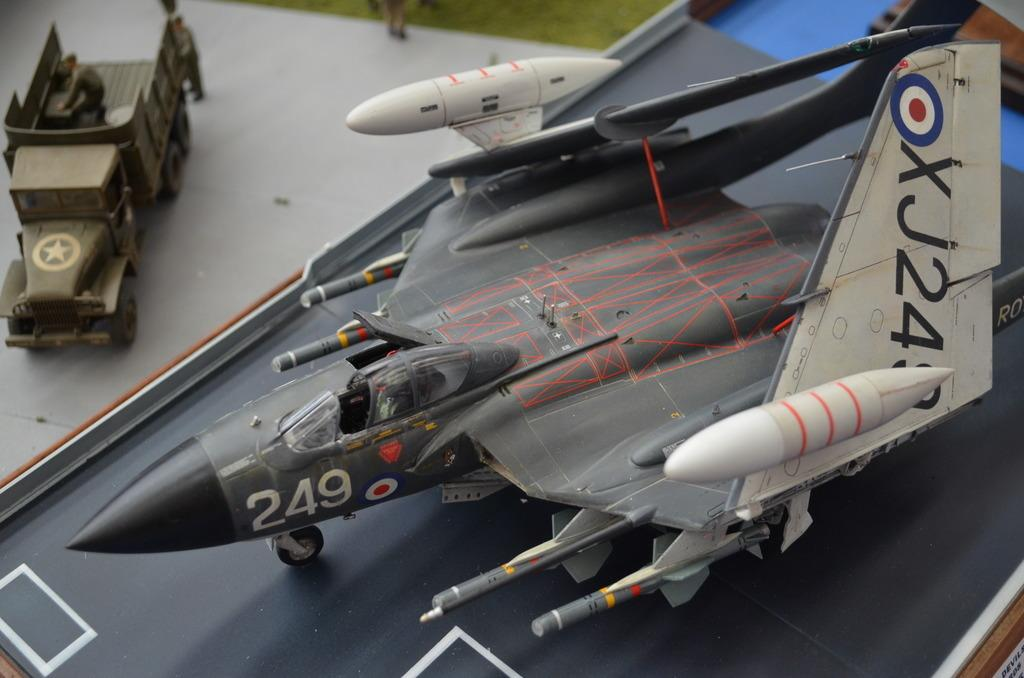What is the main object in the image? There is an aircraft toy in the image. Where is the aircraft toy located? The aircraft toy is placed on a table. What other object is present in the image? There is a military gypsy in the image. How is the military gypsy positioned in relation to the aircraft toy? The military gypsy is beside the aircraft toy. What word is written on the side of the aircraft toy in the image? There is no word written on the side of the aircraft toy in the image. What color is the chicken sitting next to the military gypsy in the image? There is no chicken present in the image. 